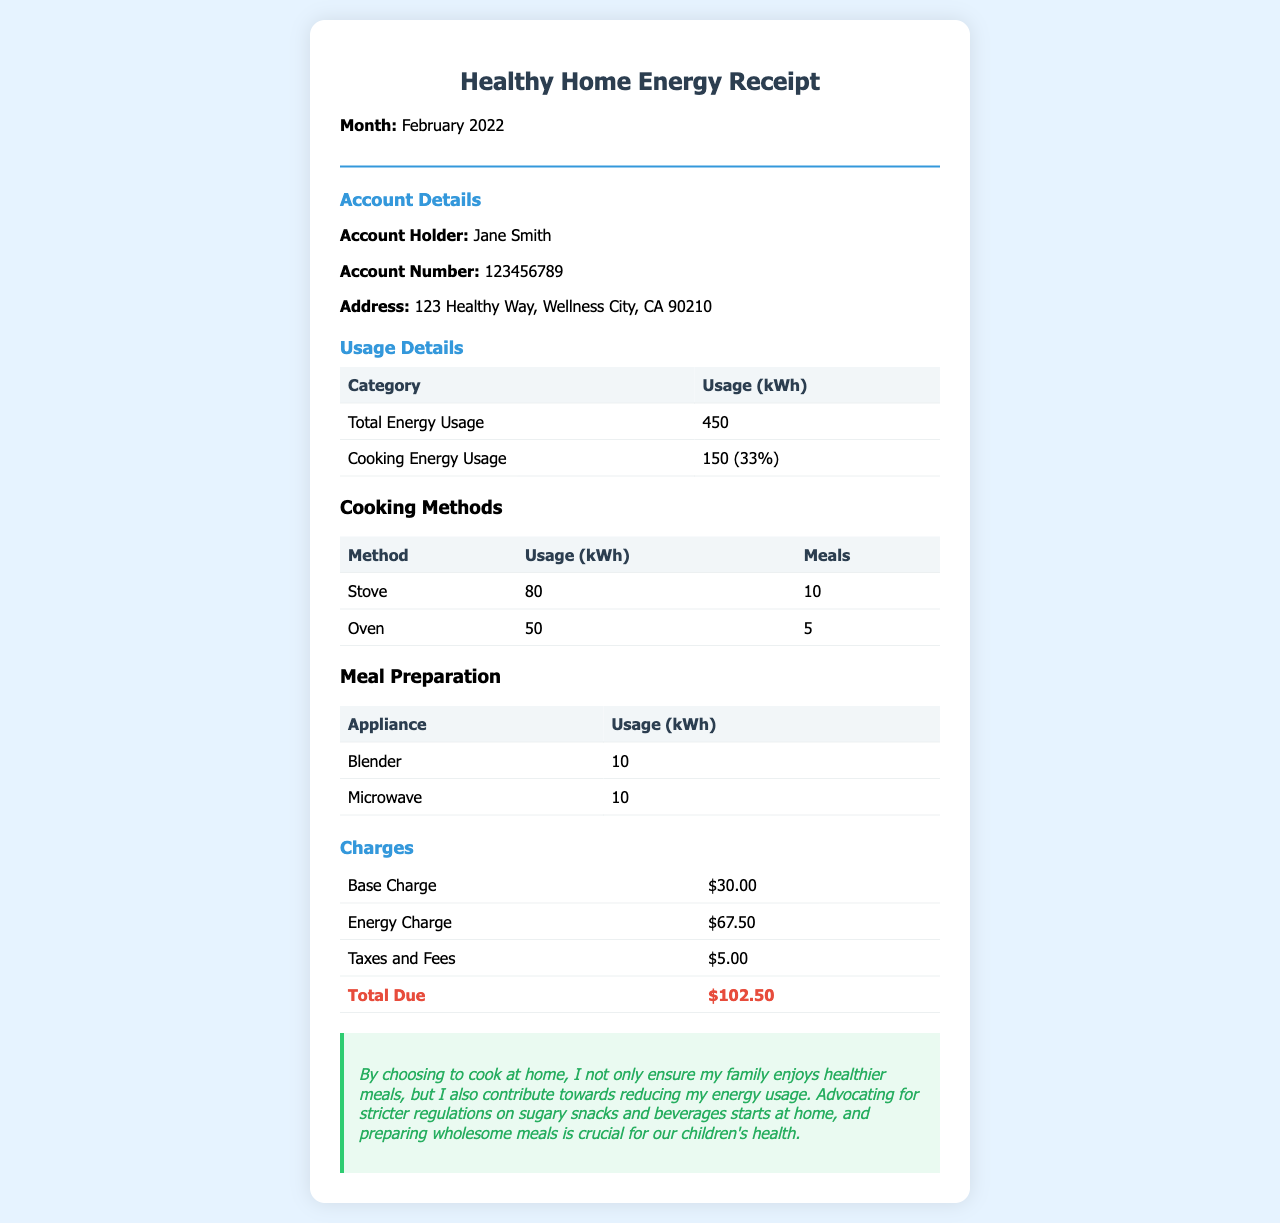What is the total energy usage? The total energy usage is mentioned in the usage details section as 450 kWh.
Answer: 450 kWh Who is the account holder? The account holder's name is provided in the account details section as Jane Smith.
Answer: Jane Smith What is the energy usage for cooking? The cooking energy usage is specified as 150 kWh, which is 33% of the total energy usage.
Answer: 150 kWh What appliance was used the most for meal preparation? The document lists the stove with an energy usage of 80 kWh, used for 10 meals, making it the most used for cooking.
Answer: Stove What is the total due amount? The total due amount can be found in the charges section as $102.50.
Answer: $102.50 How much energy was used by the oven? The energy usage for the oven is specifically listed as 50 kWh in the cooking methods section.
Answer: 50 kWh What percentage of total usage is from cooking? The document mentions that cooking energy usage is 33% of the total energy usage.
Answer: 33% What message is included related to advocacy? The advocacy message emphasizes the importance of cooking at home for healthier meals and reducing energy usage.
Answer: Advocating for stricter regulations on sugary snacks and beverages starts at home 